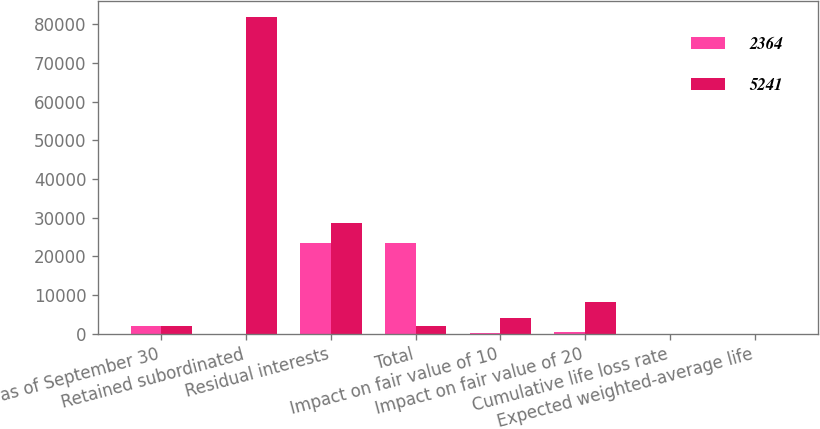<chart> <loc_0><loc_0><loc_500><loc_500><stacked_bar_chart><ecel><fcel>as of September 30<fcel>Retained subordinated<fcel>Residual interests<fcel>Total<fcel>Impact on fair value of 10<fcel>Impact on fair value of 20<fcel>Cumulative life loss rate<fcel>Expected weighted-average life<nl><fcel>2364<fcel>2010<fcel>0<fcel>23362<fcel>23362<fcel>179<fcel>355<fcel>6.9<fcel>1.5<nl><fcel>5241<fcel>2009<fcel>81886<fcel>28714<fcel>2009<fcel>4133<fcel>8225<fcel>7.4<fcel>2.2<nl></chart> 